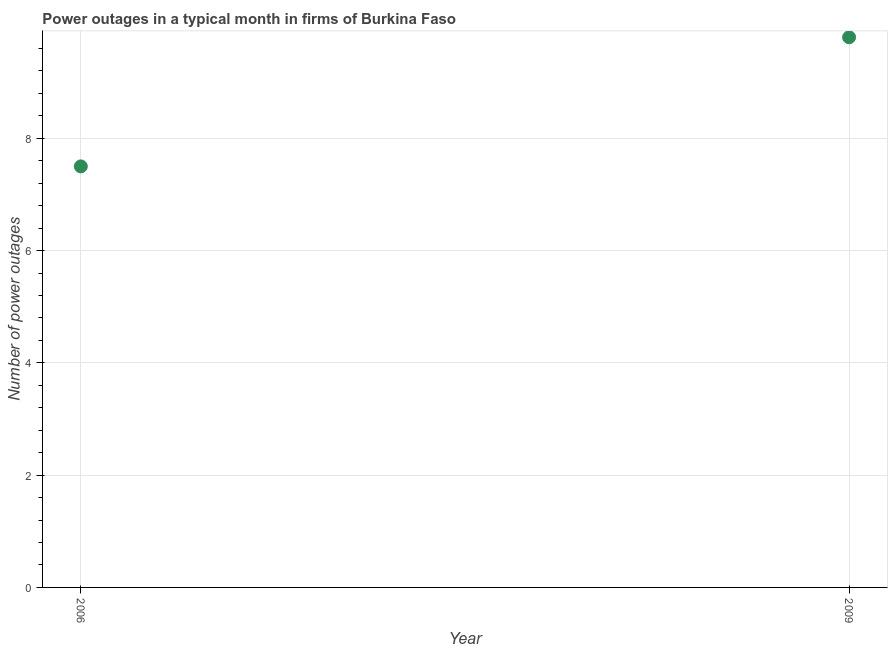What is the sum of the number of power outages?
Your response must be concise. 17.3. What is the difference between the number of power outages in 2006 and 2009?
Make the answer very short. -2.3. What is the average number of power outages per year?
Provide a succinct answer. 8.65. What is the median number of power outages?
Your answer should be very brief. 8.65. In how many years, is the number of power outages greater than 8 ?
Your answer should be very brief. 1. Do a majority of the years between 2009 and 2006 (inclusive) have number of power outages greater than 3.2 ?
Ensure brevity in your answer.  No. What is the ratio of the number of power outages in 2006 to that in 2009?
Ensure brevity in your answer.  0.77. Does the number of power outages monotonically increase over the years?
Offer a very short reply. Yes. How many dotlines are there?
Make the answer very short. 1. Are the values on the major ticks of Y-axis written in scientific E-notation?
Offer a very short reply. No. Does the graph contain any zero values?
Your response must be concise. No. What is the title of the graph?
Ensure brevity in your answer.  Power outages in a typical month in firms of Burkina Faso. What is the label or title of the X-axis?
Ensure brevity in your answer.  Year. What is the label or title of the Y-axis?
Provide a short and direct response. Number of power outages. What is the Number of power outages in 2006?
Provide a short and direct response. 7.5. What is the Number of power outages in 2009?
Ensure brevity in your answer.  9.8. What is the difference between the Number of power outages in 2006 and 2009?
Ensure brevity in your answer.  -2.3. What is the ratio of the Number of power outages in 2006 to that in 2009?
Ensure brevity in your answer.  0.77. 